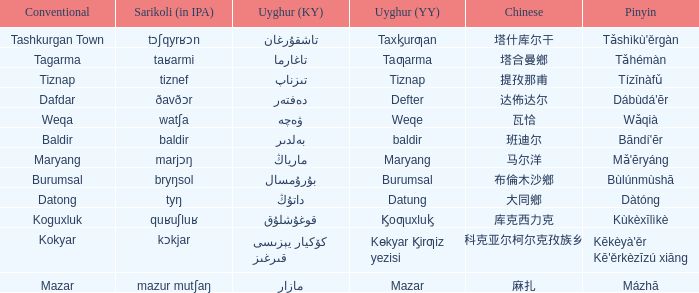Name the pinyin for  kɵkyar k̡irƣiz yezisi Kēkèyà'ěr Kē'ěrkèzīzú xiāng. 